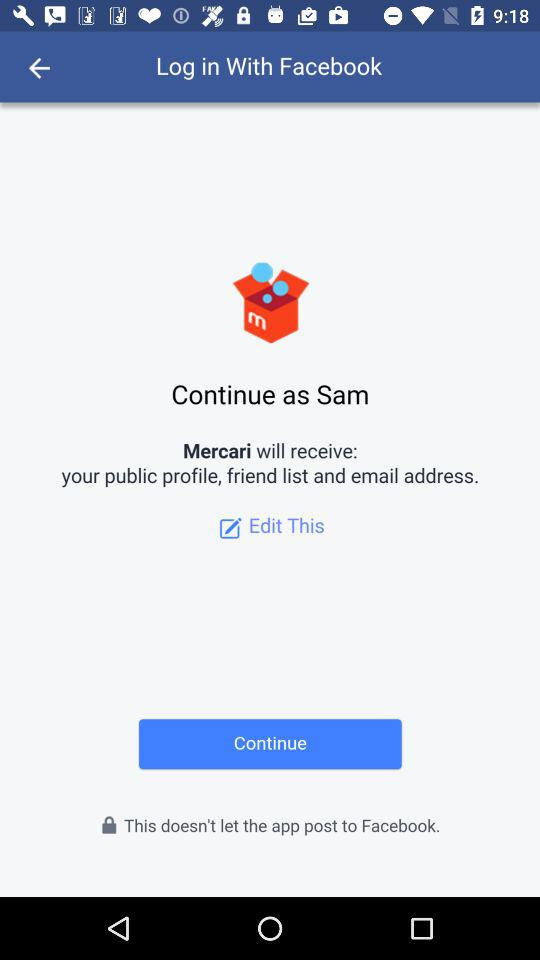What information will "Mercari" receive? "Mercari" will receive your public profile, friend list and email address. 